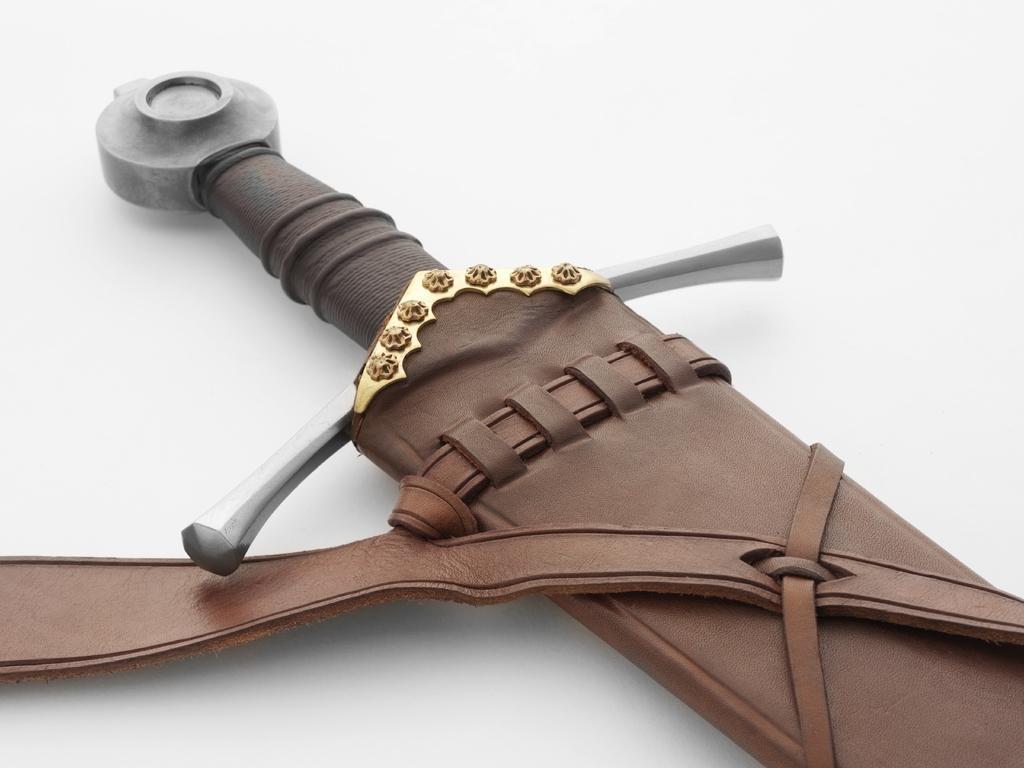How would you summarize this image in a sentence or two? In this image we can see sword placed on the table. 